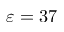Convert formula to latex. <formula><loc_0><loc_0><loc_500><loc_500>\varepsilon = 3 7</formula> 